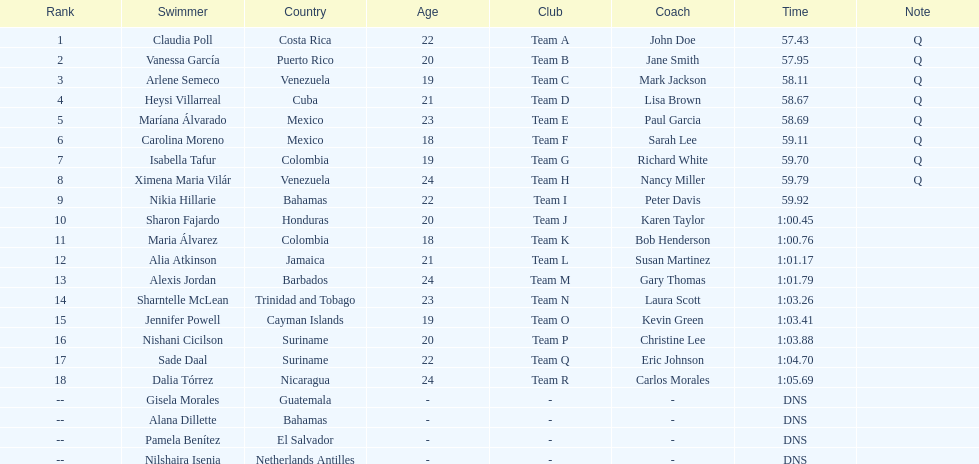How many swimmers did not swim? 4. 